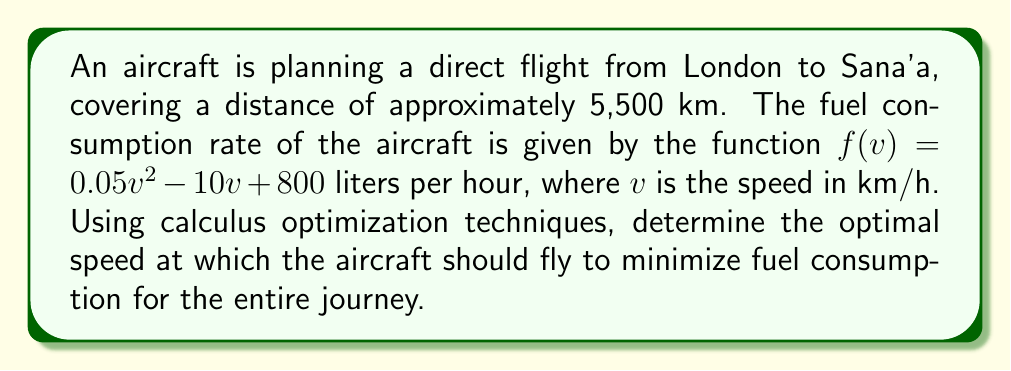What is the answer to this math problem? To solve this problem, we'll follow these steps:

1) First, we need to express the total fuel consumption in terms of speed. The time taken for the journey is distance divided by speed:

   $t = \frac{5500}{v}$ hours

2) The total fuel consumed is the product of the fuel consumption rate and time:

   $F(v) = f(v) \cdot t = (0.05v^2 - 10v + 800) \cdot \frac{5500}{v}$

3) Simplify this expression:

   $F(v) = 275v - 55000 + \frac{4400000}{v}$

4) To find the minimum fuel consumption, we need to find where the derivative of $F(v)$ equals zero:

   $F'(v) = 275 - \frac{4400000}{v^2}$

5) Set this equal to zero and solve for $v$:

   $275 - \frac{4400000}{v^2} = 0$
   $275v^2 = 4400000$
   $v^2 = 16000$
   $v = 400$ km/h (we take the positive root as speed can't be negative)

6) To confirm this is a minimum, we can check the second derivative:

   $F''(v) = \frac{8800000}{v^3}$

   At $v = 400$, $F''(400) > 0$, confirming a minimum.

Therefore, the optimal speed to minimize fuel consumption is 400 km/h.
Answer: 400 km/h 